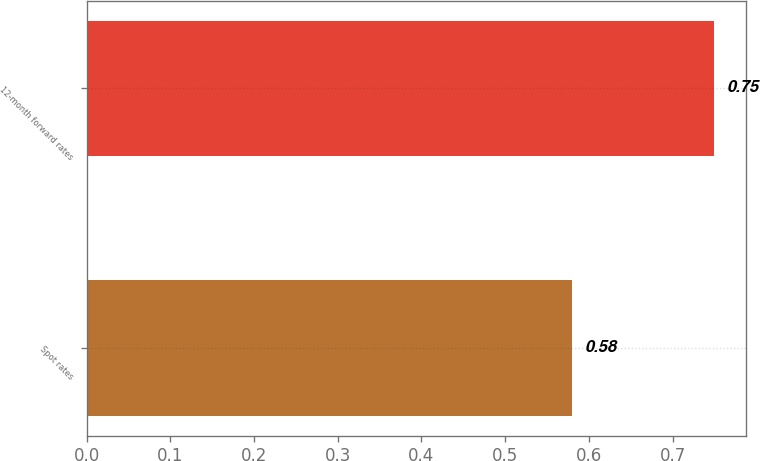<chart> <loc_0><loc_0><loc_500><loc_500><bar_chart><fcel>Spot rates<fcel>12-month forward rates<nl><fcel>0.58<fcel>0.75<nl></chart> 